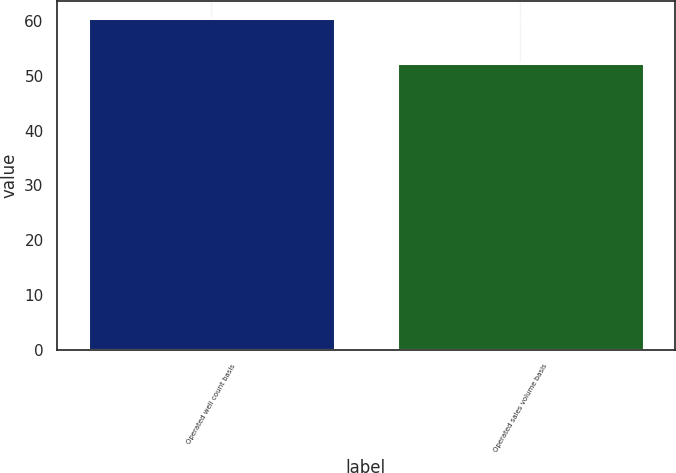Convert chart to OTSL. <chart><loc_0><loc_0><loc_500><loc_500><bar_chart><fcel>Operated well count basis<fcel>Operated sales volume basis<nl><fcel>60.6<fcel>52.3<nl></chart> 